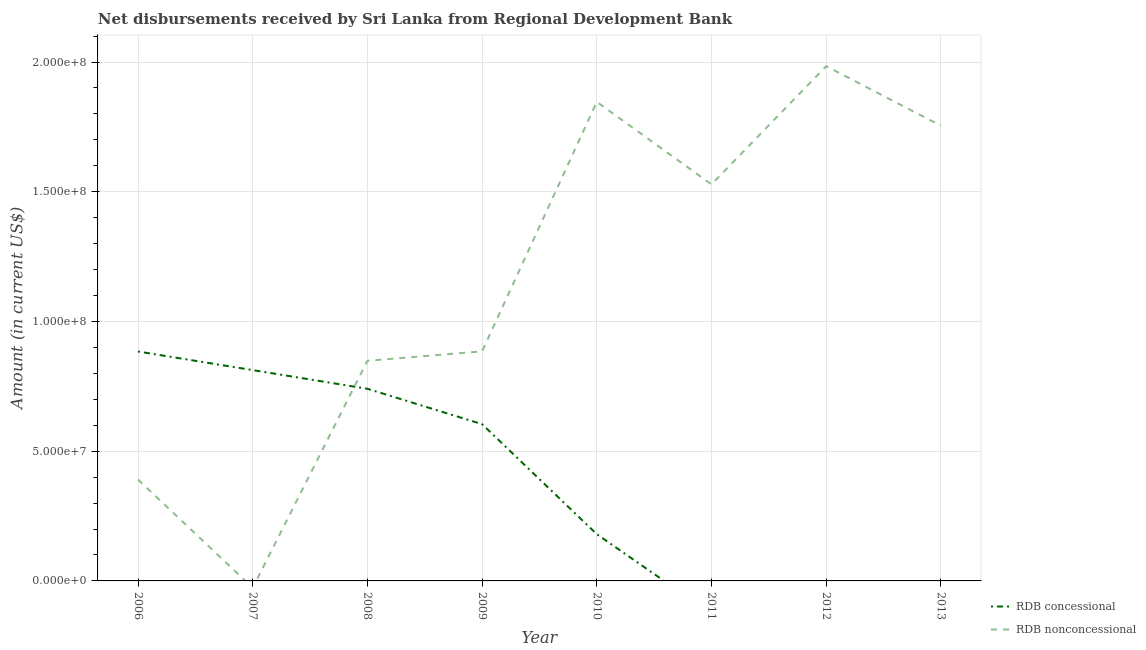How many different coloured lines are there?
Your answer should be very brief. 2. What is the net non concessional disbursements from rdb in 2006?
Make the answer very short. 3.91e+07. Across all years, what is the maximum net non concessional disbursements from rdb?
Your answer should be very brief. 1.98e+08. What is the total net concessional disbursements from rdb in the graph?
Your response must be concise. 3.22e+08. What is the difference between the net concessional disbursements from rdb in 2009 and that in 2010?
Provide a succinct answer. 4.24e+07. What is the difference between the net concessional disbursements from rdb in 2012 and the net non concessional disbursements from rdb in 2010?
Your response must be concise. -1.85e+08. What is the average net concessional disbursements from rdb per year?
Provide a succinct answer. 4.03e+07. In the year 2010, what is the difference between the net non concessional disbursements from rdb and net concessional disbursements from rdb?
Offer a terse response. 1.67e+08. In how many years, is the net concessional disbursements from rdb greater than 190000000 US$?
Provide a short and direct response. 0. What is the ratio of the net non concessional disbursements from rdb in 2010 to that in 2013?
Give a very brief answer. 1.05. What is the difference between the highest and the second highest net concessional disbursements from rdb?
Keep it short and to the point. 7.17e+06. What is the difference between the highest and the lowest net non concessional disbursements from rdb?
Provide a short and direct response. 1.98e+08. Is the net concessional disbursements from rdb strictly greater than the net non concessional disbursements from rdb over the years?
Ensure brevity in your answer.  No. Is the net non concessional disbursements from rdb strictly less than the net concessional disbursements from rdb over the years?
Your answer should be very brief. No. How many years are there in the graph?
Provide a short and direct response. 8. Are the values on the major ticks of Y-axis written in scientific E-notation?
Your response must be concise. Yes. Does the graph contain grids?
Your answer should be very brief. Yes. Where does the legend appear in the graph?
Ensure brevity in your answer.  Bottom right. How are the legend labels stacked?
Provide a succinct answer. Vertical. What is the title of the graph?
Make the answer very short. Net disbursements received by Sri Lanka from Regional Development Bank. What is the label or title of the X-axis?
Ensure brevity in your answer.  Year. What is the label or title of the Y-axis?
Provide a short and direct response. Amount (in current US$). What is the Amount (in current US$) of RDB concessional in 2006?
Your answer should be compact. 8.84e+07. What is the Amount (in current US$) of RDB nonconcessional in 2006?
Provide a short and direct response. 3.91e+07. What is the Amount (in current US$) of RDB concessional in 2007?
Keep it short and to the point. 8.13e+07. What is the Amount (in current US$) in RDB concessional in 2008?
Keep it short and to the point. 7.41e+07. What is the Amount (in current US$) of RDB nonconcessional in 2008?
Provide a succinct answer. 8.48e+07. What is the Amount (in current US$) in RDB concessional in 2009?
Ensure brevity in your answer.  6.04e+07. What is the Amount (in current US$) of RDB nonconcessional in 2009?
Offer a very short reply. 8.85e+07. What is the Amount (in current US$) of RDB concessional in 2010?
Give a very brief answer. 1.80e+07. What is the Amount (in current US$) in RDB nonconcessional in 2010?
Ensure brevity in your answer.  1.85e+08. What is the Amount (in current US$) in RDB nonconcessional in 2011?
Keep it short and to the point. 1.53e+08. What is the Amount (in current US$) of RDB concessional in 2012?
Your response must be concise. 0. What is the Amount (in current US$) of RDB nonconcessional in 2012?
Provide a succinct answer. 1.98e+08. What is the Amount (in current US$) in RDB concessional in 2013?
Offer a very short reply. 0. What is the Amount (in current US$) in RDB nonconcessional in 2013?
Your response must be concise. 1.75e+08. Across all years, what is the maximum Amount (in current US$) in RDB concessional?
Your answer should be very brief. 8.84e+07. Across all years, what is the maximum Amount (in current US$) of RDB nonconcessional?
Offer a very short reply. 1.98e+08. Across all years, what is the minimum Amount (in current US$) in RDB concessional?
Your answer should be very brief. 0. Across all years, what is the minimum Amount (in current US$) in RDB nonconcessional?
Provide a short and direct response. 0. What is the total Amount (in current US$) in RDB concessional in the graph?
Your answer should be very brief. 3.22e+08. What is the total Amount (in current US$) in RDB nonconcessional in the graph?
Provide a succinct answer. 9.24e+08. What is the difference between the Amount (in current US$) of RDB concessional in 2006 and that in 2007?
Offer a very short reply. 7.17e+06. What is the difference between the Amount (in current US$) in RDB concessional in 2006 and that in 2008?
Your answer should be very brief. 1.44e+07. What is the difference between the Amount (in current US$) of RDB nonconcessional in 2006 and that in 2008?
Your answer should be compact. -4.58e+07. What is the difference between the Amount (in current US$) in RDB concessional in 2006 and that in 2009?
Provide a succinct answer. 2.80e+07. What is the difference between the Amount (in current US$) in RDB nonconcessional in 2006 and that in 2009?
Give a very brief answer. -4.94e+07. What is the difference between the Amount (in current US$) in RDB concessional in 2006 and that in 2010?
Make the answer very short. 7.04e+07. What is the difference between the Amount (in current US$) of RDB nonconcessional in 2006 and that in 2010?
Offer a terse response. -1.46e+08. What is the difference between the Amount (in current US$) in RDB nonconcessional in 2006 and that in 2011?
Provide a succinct answer. -1.14e+08. What is the difference between the Amount (in current US$) of RDB nonconcessional in 2006 and that in 2012?
Keep it short and to the point. -1.59e+08. What is the difference between the Amount (in current US$) of RDB nonconcessional in 2006 and that in 2013?
Offer a terse response. -1.36e+08. What is the difference between the Amount (in current US$) in RDB concessional in 2007 and that in 2008?
Ensure brevity in your answer.  7.20e+06. What is the difference between the Amount (in current US$) in RDB concessional in 2007 and that in 2009?
Your answer should be very brief. 2.08e+07. What is the difference between the Amount (in current US$) in RDB concessional in 2007 and that in 2010?
Ensure brevity in your answer.  6.32e+07. What is the difference between the Amount (in current US$) of RDB concessional in 2008 and that in 2009?
Your answer should be compact. 1.36e+07. What is the difference between the Amount (in current US$) in RDB nonconcessional in 2008 and that in 2009?
Provide a succinct answer. -3.64e+06. What is the difference between the Amount (in current US$) of RDB concessional in 2008 and that in 2010?
Offer a terse response. 5.60e+07. What is the difference between the Amount (in current US$) of RDB nonconcessional in 2008 and that in 2010?
Your answer should be very brief. -9.98e+07. What is the difference between the Amount (in current US$) of RDB nonconcessional in 2008 and that in 2011?
Make the answer very short. -6.80e+07. What is the difference between the Amount (in current US$) of RDB nonconcessional in 2008 and that in 2012?
Your answer should be compact. -1.14e+08. What is the difference between the Amount (in current US$) of RDB nonconcessional in 2008 and that in 2013?
Make the answer very short. -9.06e+07. What is the difference between the Amount (in current US$) of RDB concessional in 2009 and that in 2010?
Your answer should be very brief. 4.24e+07. What is the difference between the Amount (in current US$) in RDB nonconcessional in 2009 and that in 2010?
Provide a succinct answer. -9.62e+07. What is the difference between the Amount (in current US$) in RDB nonconcessional in 2009 and that in 2011?
Provide a short and direct response. -6.44e+07. What is the difference between the Amount (in current US$) of RDB nonconcessional in 2009 and that in 2012?
Provide a succinct answer. -1.10e+08. What is the difference between the Amount (in current US$) in RDB nonconcessional in 2009 and that in 2013?
Your answer should be compact. -8.70e+07. What is the difference between the Amount (in current US$) of RDB nonconcessional in 2010 and that in 2011?
Make the answer very short. 3.18e+07. What is the difference between the Amount (in current US$) of RDB nonconcessional in 2010 and that in 2012?
Your response must be concise. -1.38e+07. What is the difference between the Amount (in current US$) in RDB nonconcessional in 2010 and that in 2013?
Offer a very short reply. 9.17e+06. What is the difference between the Amount (in current US$) in RDB nonconcessional in 2011 and that in 2012?
Make the answer very short. -4.56e+07. What is the difference between the Amount (in current US$) of RDB nonconcessional in 2011 and that in 2013?
Ensure brevity in your answer.  -2.26e+07. What is the difference between the Amount (in current US$) in RDB nonconcessional in 2012 and that in 2013?
Offer a very short reply. 2.29e+07. What is the difference between the Amount (in current US$) of RDB concessional in 2006 and the Amount (in current US$) of RDB nonconcessional in 2008?
Your answer should be very brief. 3.58e+06. What is the difference between the Amount (in current US$) of RDB concessional in 2006 and the Amount (in current US$) of RDB nonconcessional in 2009?
Give a very brief answer. -6.60e+04. What is the difference between the Amount (in current US$) in RDB concessional in 2006 and the Amount (in current US$) in RDB nonconcessional in 2010?
Ensure brevity in your answer.  -9.62e+07. What is the difference between the Amount (in current US$) of RDB concessional in 2006 and the Amount (in current US$) of RDB nonconcessional in 2011?
Your answer should be compact. -6.44e+07. What is the difference between the Amount (in current US$) of RDB concessional in 2006 and the Amount (in current US$) of RDB nonconcessional in 2012?
Give a very brief answer. -1.10e+08. What is the difference between the Amount (in current US$) in RDB concessional in 2006 and the Amount (in current US$) in RDB nonconcessional in 2013?
Provide a succinct answer. -8.70e+07. What is the difference between the Amount (in current US$) of RDB concessional in 2007 and the Amount (in current US$) of RDB nonconcessional in 2008?
Provide a succinct answer. -3.59e+06. What is the difference between the Amount (in current US$) in RDB concessional in 2007 and the Amount (in current US$) in RDB nonconcessional in 2009?
Provide a succinct answer. -7.24e+06. What is the difference between the Amount (in current US$) of RDB concessional in 2007 and the Amount (in current US$) of RDB nonconcessional in 2010?
Offer a terse response. -1.03e+08. What is the difference between the Amount (in current US$) of RDB concessional in 2007 and the Amount (in current US$) of RDB nonconcessional in 2011?
Your answer should be compact. -7.16e+07. What is the difference between the Amount (in current US$) of RDB concessional in 2007 and the Amount (in current US$) of RDB nonconcessional in 2012?
Give a very brief answer. -1.17e+08. What is the difference between the Amount (in current US$) of RDB concessional in 2007 and the Amount (in current US$) of RDB nonconcessional in 2013?
Offer a very short reply. -9.42e+07. What is the difference between the Amount (in current US$) in RDB concessional in 2008 and the Amount (in current US$) in RDB nonconcessional in 2009?
Provide a succinct answer. -1.44e+07. What is the difference between the Amount (in current US$) in RDB concessional in 2008 and the Amount (in current US$) in RDB nonconcessional in 2010?
Provide a succinct answer. -1.11e+08. What is the difference between the Amount (in current US$) of RDB concessional in 2008 and the Amount (in current US$) of RDB nonconcessional in 2011?
Your response must be concise. -7.88e+07. What is the difference between the Amount (in current US$) of RDB concessional in 2008 and the Amount (in current US$) of RDB nonconcessional in 2012?
Provide a short and direct response. -1.24e+08. What is the difference between the Amount (in current US$) of RDB concessional in 2008 and the Amount (in current US$) of RDB nonconcessional in 2013?
Make the answer very short. -1.01e+08. What is the difference between the Amount (in current US$) of RDB concessional in 2009 and the Amount (in current US$) of RDB nonconcessional in 2010?
Provide a succinct answer. -1.24e+08. What is the difference between the Amount (in current US$) in RDB concessional in 2009 and the Amount (in current US$) in RDB nonconcessional in 2011?
Your answer should be very brief. -9.24e+07. What is the difference between the Amount (in current US$) in RDB concessional in 2009 and the Amount (in current US$) in RDB nonconcessional in 2012?
Provide a short and direct response. -1.38e+08. What is the difference between the Amount (in current US$) in RDB concessional in 2009 and the Amount (in current US$) in RDB nonconcessional in 2013?
Your response must be concise. -1.15e+08. What is the difference between the Amount (in current US$) in RDB concessional in 2010 and the Amount (in current US$) in RDB nonconcessional in 2011?
Provide a succinct answer. -1.35e+08. What is the difference between the Amount (in current US$) of RDB concessional in 2010 and the Amount (in current US$) of RDB nonconcessional in 2012?
Ensure brevity in your answer.  -1.80e+08. What is the difference between the Amount (in current US$) in RDB concessional in 2010 and the Amount (in current US$) in RDB nonconcessional in 2013?
Make the answer very short. -1.57e+08. What is the average Amount (in current US$) of RDB concessional per year?
Make the answer very short. 4.03e+07. What is the average Amount (in current US$) in RDB nonconcessional per year?
Your answer should be compact. 1.15e+08. In the year 2006, what is the difference between the Amount (in current US$) of RDB concessional and Amount (in current US$) of RDB nonconcessional?
Provide a short and direct response. 4.94e+07. In the year 2008, what is the difference between the Amount (in current US$) of RDB concessional and Amount (in current US$) of RDB nonconcessional?
Provide a short and direct response. -1.08e+07. In the year 2009, what is the difference between the Amount (in current US$) in RDB concessional and Amount (in current US$) in RDB nonconcessional?
Make the answer very short. -2.81e+07. In the year 2010, what is the difference between the Amount (in current US$) in RDB concessional and Amount (in current US$) in RDB nonconcessional?
Give a very brief answer. -1.67e+08. What is the ratio of the Amount (in current US$) of RDB concessional in 2006 to that in 2007?
Make the answer very short. 1.09. What is the ratio of the Amount (in current US$) in RDB concessional in 2006 to that in 2008?
Your answer should be compact. 1.19. What is the ratio of the Amount (in current US$) in RDB nonconcessional in 2006 to that in 2008?
Your answer should be compact. 0.46. What is the ratio of the Amount (in current US$) of RDB concessional in 2006 to that in 2009?
Your response must be concise. 1.46. What is the ratio of the Amount (in current US$) in RDB nonconcessional in 2006 to that in 2009?
Provide a short and direct response. 0.44. What is the ratio of the Amount (in current US$) of RDB concessional in 2006 to that in 2010?
Your answer should be compact. 4.91. What is the ratio of the Amount (in current US$) in RDB nonconcessional in 2006 to that in 2010?
Your response must be concise. 0.21. What is the ratio of the Amount (in current US$) of RDB nonconcessional in 2006 to that in 2011?
Offer a very short reply. 0.26. What is the ratio of the Amount (in current US$) in RDB nonconcessional in 2006 to that in 2012?
Provide a succinct answer. 0.2. What is the ratio of the Amount (in current US$) of RDB nonconcessional in 2006 to that in 2013?
Your answer should be very brief. 0.22. What is the ratio of the Amount (in current US$) of RDB concessional in 2007 to that in 2008?
Provide a succinct answer. 1.1. What is the ratio of the Amount (in current US$) in RDB concessional in 2007 to that in 2009?
Give a very brief answer. 1.34. What is the ratio of the Amount (in current US$) in RDB concessional in 2007 to that in 2010?
Offer a very short reply. 4.51. What is the ratio of the Amount (in current US$) in RDB concessional in 2008 to that in 2009?
Give a very brief answer. 1.23. What is the ratio of the Amount (in current US$) of RDB nonconcessional in 2008 to that in 2009?
Offer a very short reply. 0.96. What is the ratio of the Amount (in current US$) in RDB concessional in 2008 to that in 2010?
Your answer should be very brief. 4.11. What is the ratio of the Amount (in current US$) of RDB nonconcessional in 2008 to that in 2010?
Provide a short and direct response. 0.46. What is the ratio of the Amount (in current US$) of RDB nonconcessional in 2008 to that in 2011?
Give a very brief answer. 0.56. What is the ratio of the Amount (in current US$) in RDB nonconcessional in 2008 to that in 2012?
Provide a short and direct response. 0.43. What is the ratio of the Amount (in current US$) in RDB nonconcessional in 2008 to that in 2013?
Provide a short and direct response. 0.48. What is the ratio of the Amount (in current US$) in RDB concessional in 2009 to that in 2010?
Provide a succinct answer. 3.35. What is the ratio of the Amount (in current US$) in RDB nonconcessional in 2009 to that in 2010?
Your response must be concise. 0.48. What is the ratio of the Amount (in current US$) of RDB nonconcessional in 2009 to that in 2011?
Provide a short and direct response. 0.58. What is the ratio of the Amount (in current US$) in RDB nonconcessional in 2009 to that in 2012?
Ensure brevity in your answer.  0.45. What is the ratio of the Amount (in current US$) in RDB nonconcessional in 2009 to that in 2013?
Your answer should be compact. 0.5. What is the ratio of the Amount (in current US$) in RDB nonconcessional in 2010 to that in 2011?
Provide a succinct answer. 1.21. What is the ratio of the Amount (in current US$) in RDB nonconcessional in 2010 to that in 2012?
Offer a terse response. 0.93. What is the ratio of the Amount (in current US$) in RDB nonconcessional in 2010 to that in 2013?
Ensure brevity in your answer.  1.05. What is the ratio of the Amount (in current US$) in RDB nonconcessional in 2011 to that in 2012?
Provide a short and direct response. 0.77. What is the ratio of the Amount (in current US$) in RDB nonconcessional in 2011 to that in 2013?
Offer a terse response. 0.87. What is the ratio of the Amount (in current US$) of RDB nonconcessional in 2012 to that in 2013?
Make the answer very short. 1.13. What is the difference between the highest and the second highest Amount (in current US$) in RDB concessional?
Ensure brevity in your answer.  7.17e+06. What is the difference between the highest and the second highest Amount (in current US$) of RDB nonconcessional?
Ensure brevity in your answer.  1.38e+07. What is the difference between the highest and the lowest Amount (in current US$) of RDB concessional?
Provide a succinct answer. 8.84e+07. What is the difference between the highest and the lowest Amount (in current US$) of RDB nonconcessional?
Provide a short and direct response. 1.98e+08. 